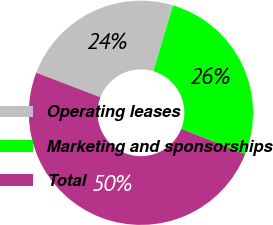Convert chart. <chart><loc_0><loc_0><loc_500><loc_500><pie_chart><fcel>Operating leases<fcel>Marketing and sponsorships<fcel>Total<nl><fcel>23.8%<fcel>26.4%<fcel>49.8%<nl></chart> 